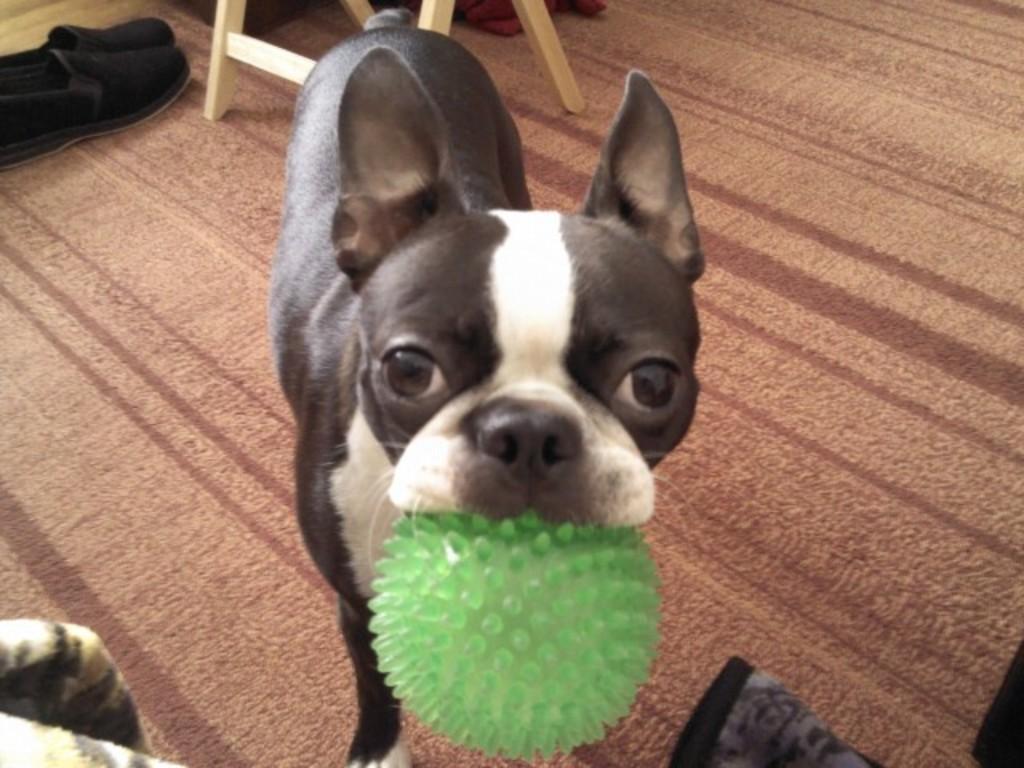Can you describe this image briefly? In this image I can see the dog which is in black, brown and white color. I can see the green color object in the mouth of dog. To the left I can see the shoes and the wooden object. These are on the mat. 